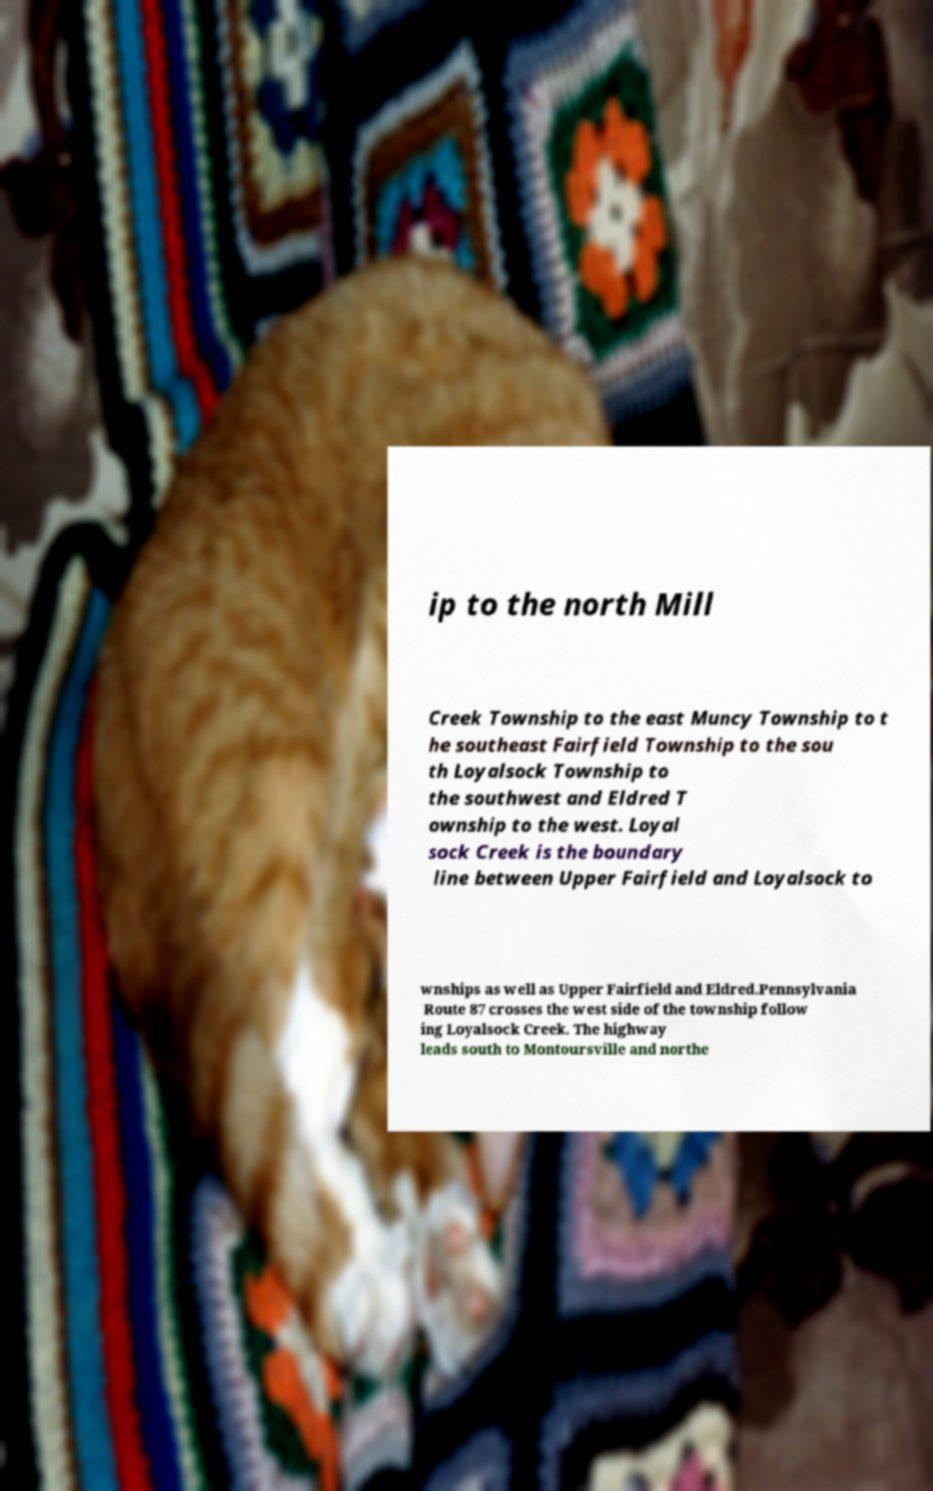Can you accurately transcribe the text from the provided image for me? ip to the north Mill Creek Township to the east Muncy Township to t he southeast Fairfield Township to the sou th Loyalsock Township to the southwest and Eldred T ownship to the west. Loyal sock Creek is the boundary line between Upper Fairfield and Loyalsock to wnships as well as Upper Fairfield and Eldred.Pennsylvania Route 87 crosses the west side of the township follow ing Loyalsock Creek. The highway leads south to Montoursville and northe 